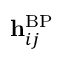Convert formula to latex. <formula><loc_0><loc_0><loc_500><loc_500>h _ { i j } ^ { B P }</formula> 